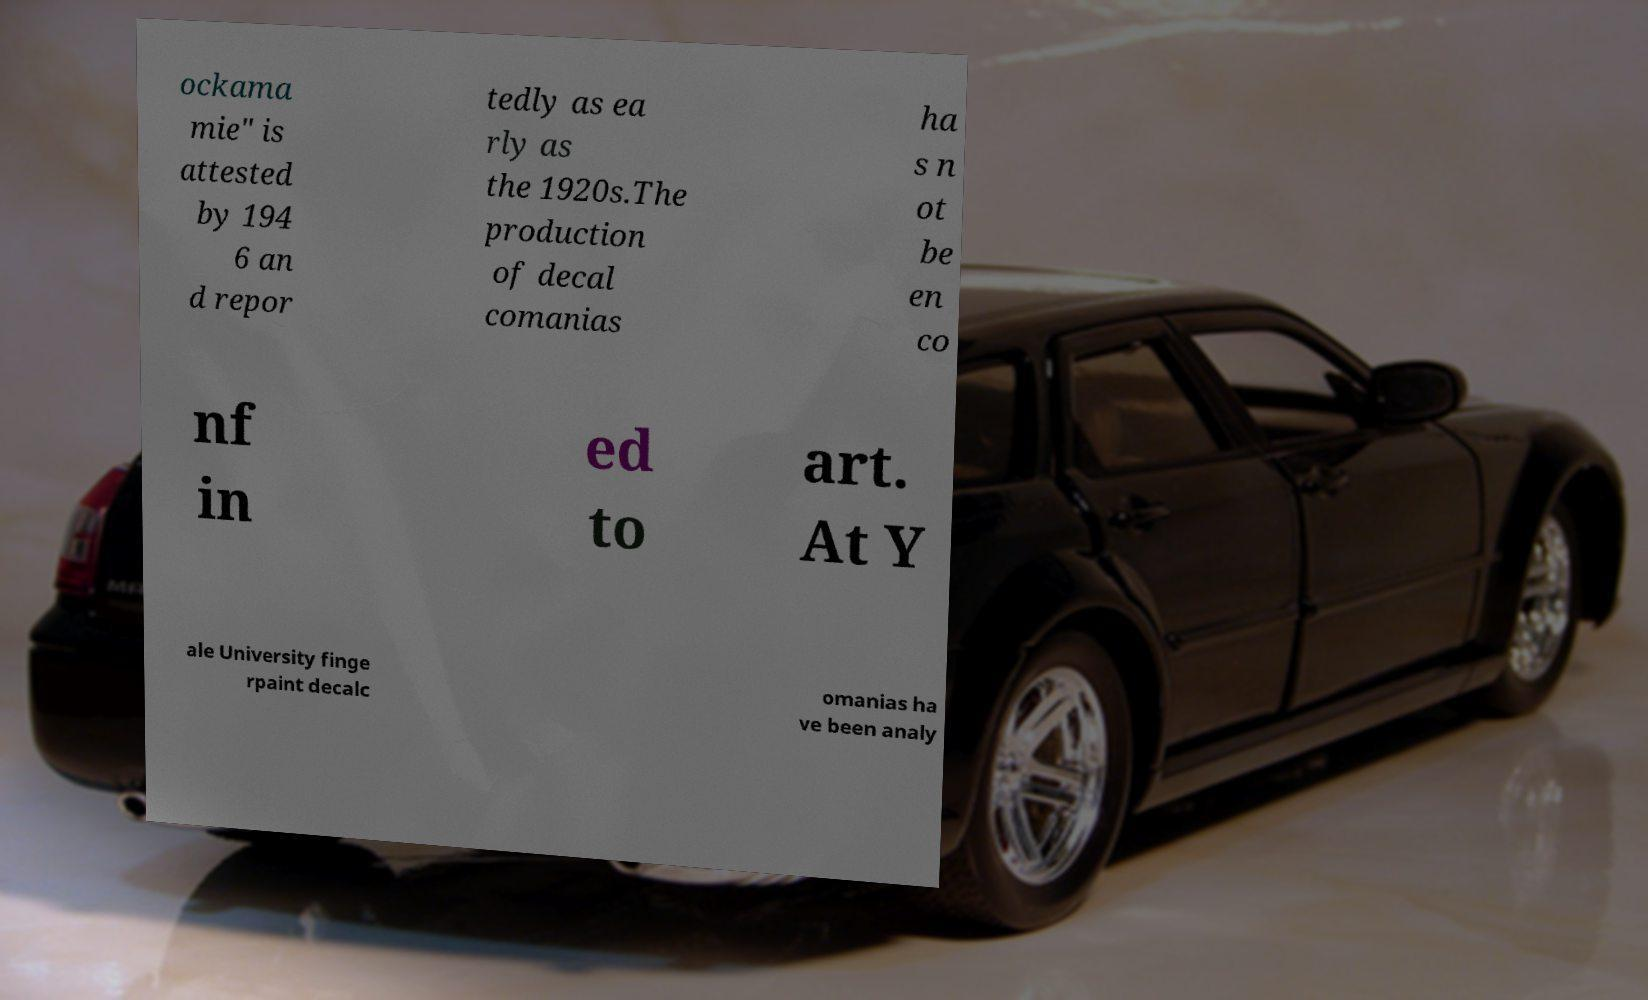Could you extract and type out the text from this image? ockama mie" is attested by 194 6 an d repor tedly as ea rly as the 1920s.The production of decal comanias ha s n ot be en co nf in ed to art. At Y ale University finge rpaint decalc omanias ha ve been analy 